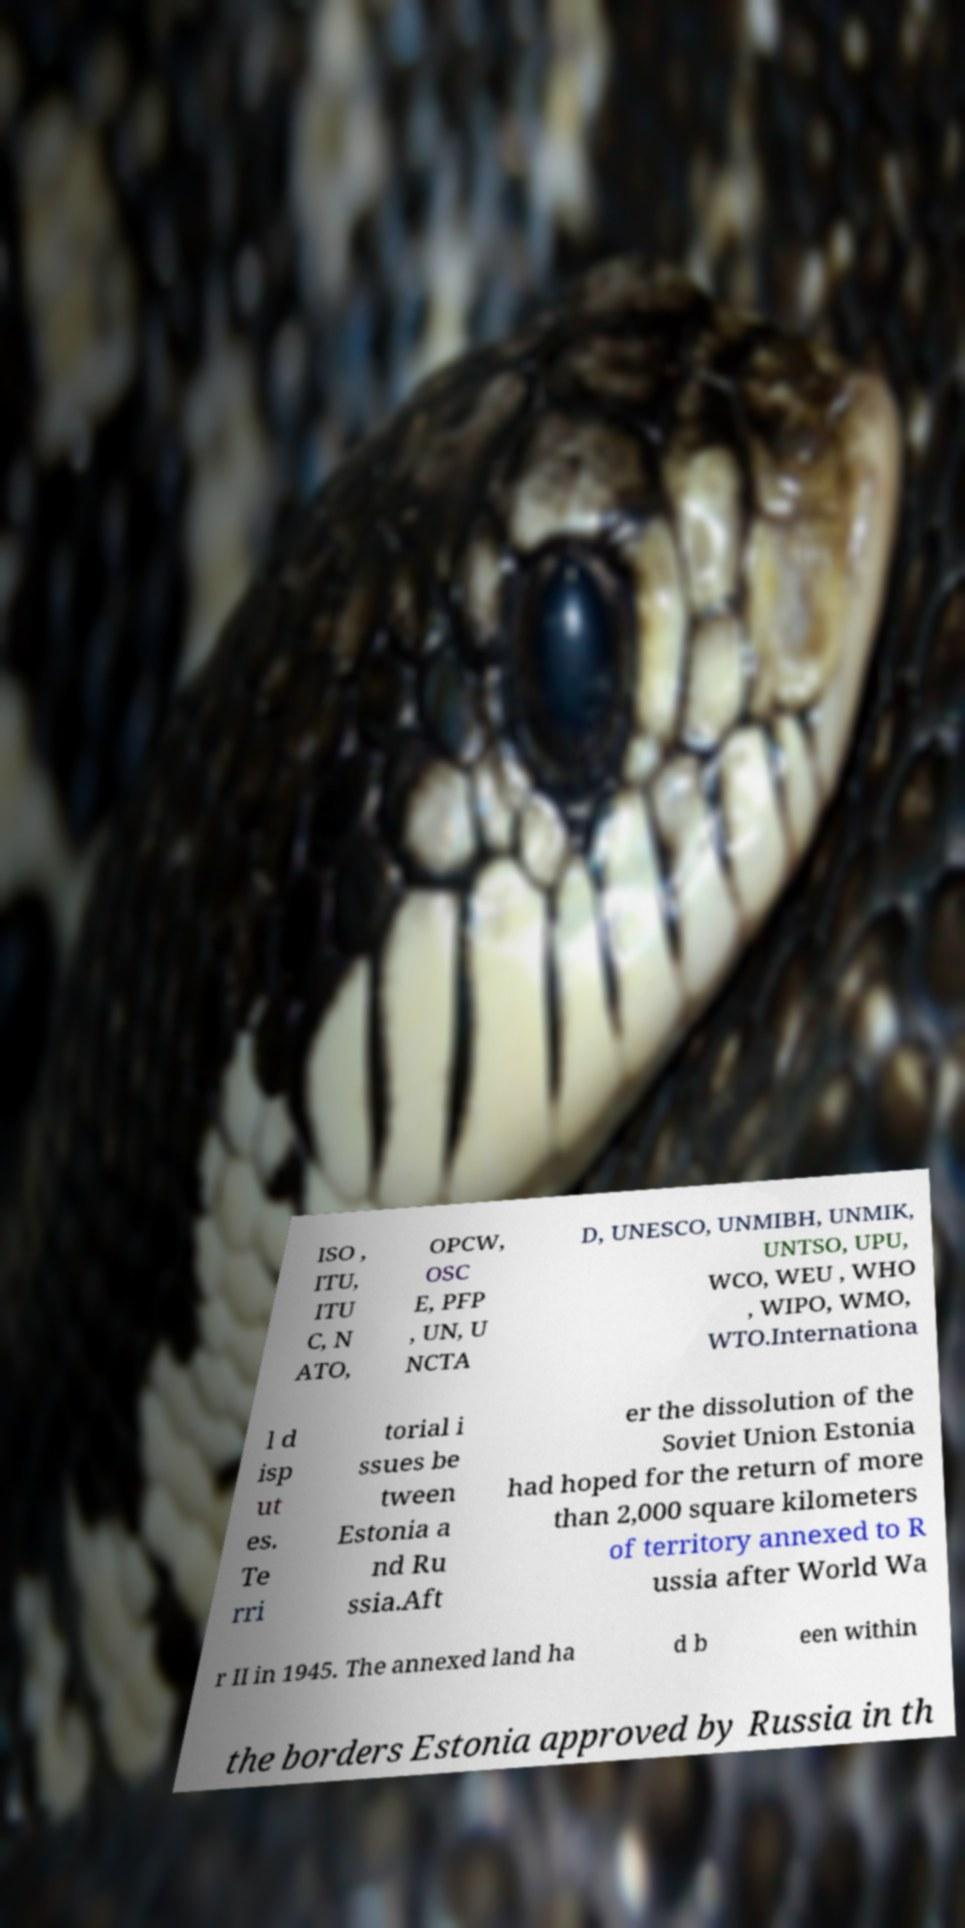Can you accurately transcribe the text from the provided image for me? ISO , ITU, ITU C, N ATO, OPCW, OSC E, PFP , UN, U NCTA D, UNESCO, UNMIBH, UNMIK, UNTSO, UPU, WCO, WEU , WHO , WIPO, WMO, WTO.Internationa l d isp ut es. Te rri torial i ssues be tween Estonia a nd Ru ssia.Aft er the dissolution of the Soviet Union Estonia had hoped for the return of more than 2,000 square kilometers of territory annexed to R ussia after World Wa r II in 1945. The annexed land ha d b een within the borders Estonia approved by Russia in th 